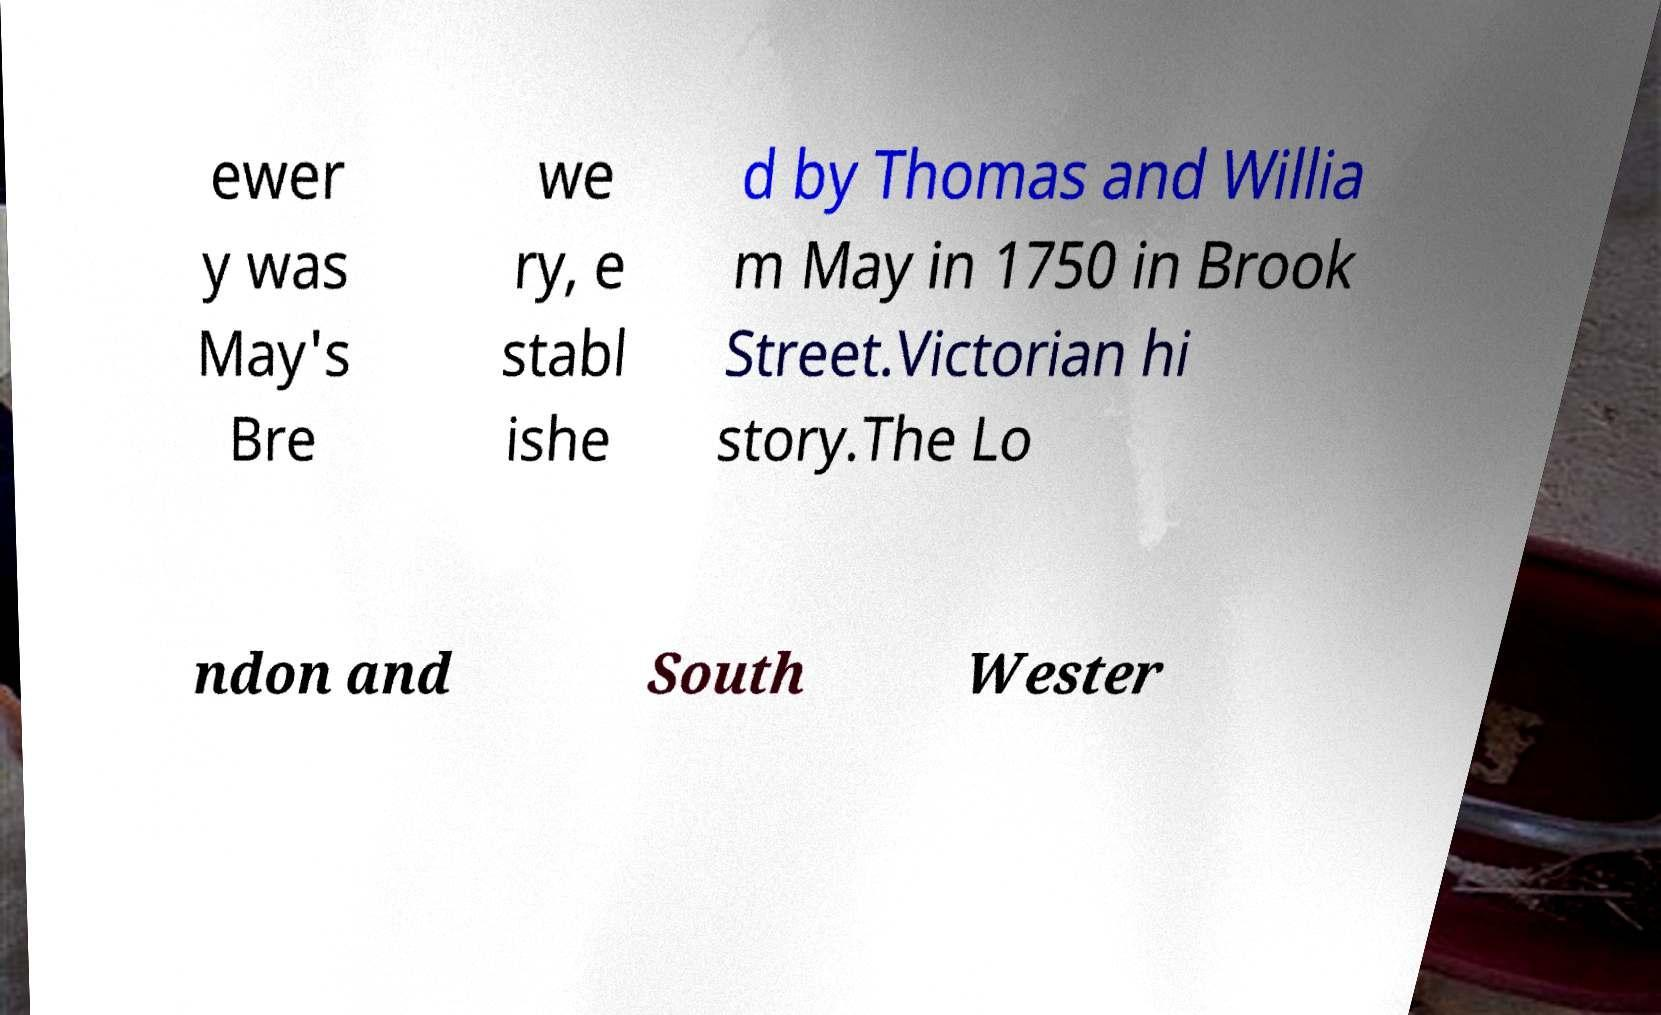There's text embedded in this image that I need extracted. Can you transcribe it verbatim? ewer y was May's Bre we ry, e stabl ishe d by Thomas and Willia m May in 1750 in Brook Street.Victorian hi story.The Lo ndon and South Wester 